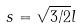Convert formula to latex. <formula><loc_0><loc_0><loc_500><loc_500>s = \sqrt { 3 / 2 } l</formula> 